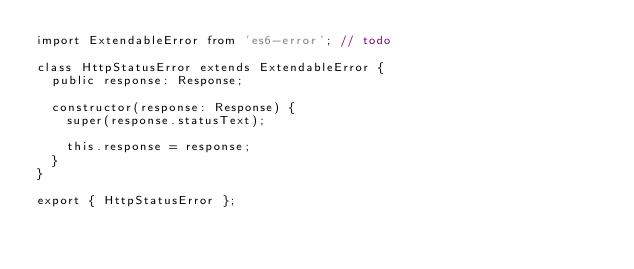Convert code to text. <code><loc_0><loc_0><loc_500><loc_500><_TypeScript_>import ExtendableError from 'es6-error'; // todo

class HttpStatusError extends ExtendableError {
  public response: Response;

  constructor(response: Response) {
    super(response.statusText);

    this.response = response;
  }
}

export { HttpStatusError };
</code> 